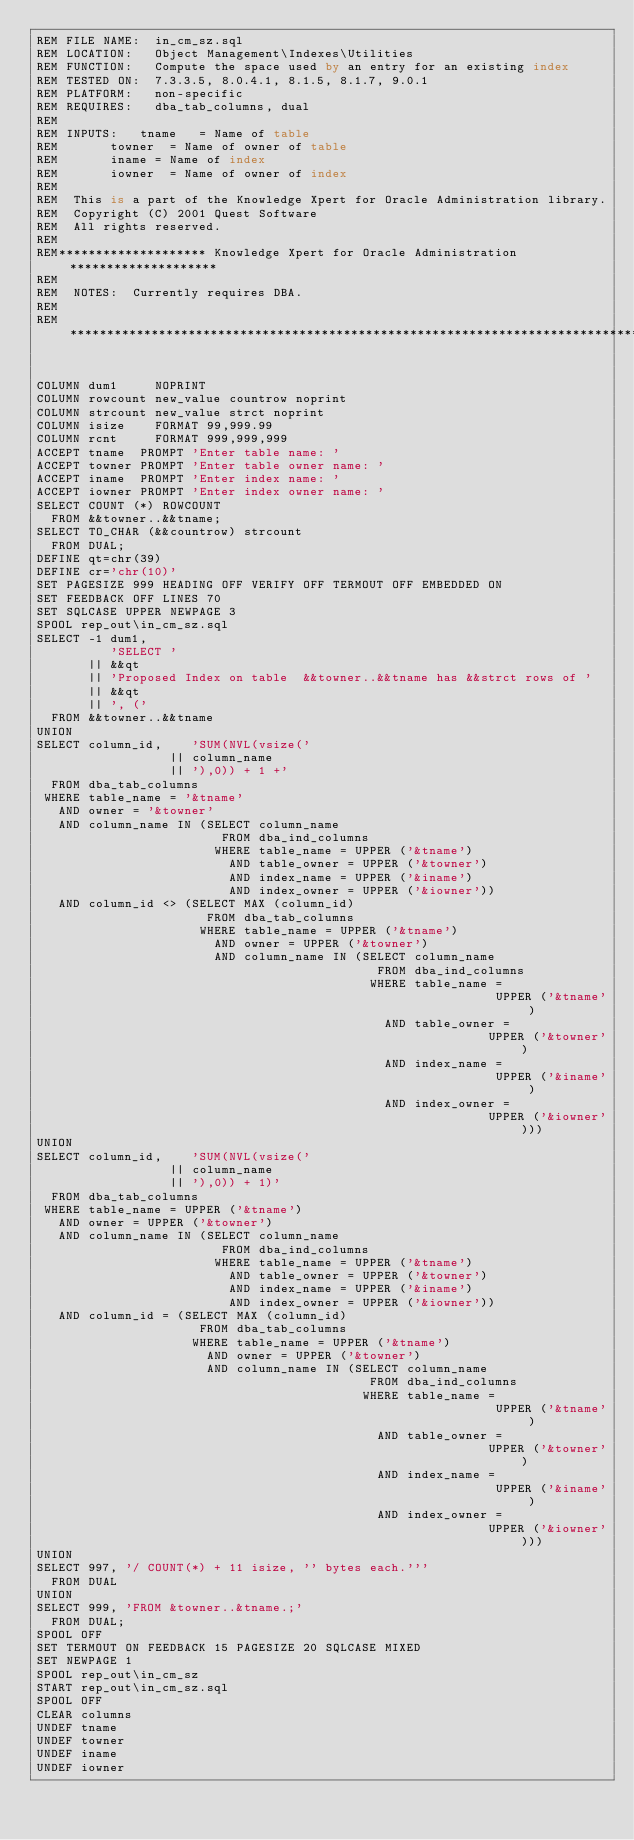<code> <loc_0><loc_0><loc_500><loc_500><_SQL_>REM FILE NAME:  in_cm_sz.sql
REM LOCATION:   Object Management\Indexes\Utilities
REM FUNCTION:   Compute the space used by an entry for an existing index
REM TESTED ON:  7.3.3.5, 8.0.4.1, 8.1.5, 8.1.7, 9.0.1
REM PLATFORM:   non-specific
REM REQUIRES:   dba_tab_columns, dual
REM
REM INPUTS:		tname 	= Name of table
REM				towner	= Name of owner of table
REM				iname	= Name of index
REM				iowner 	= Name of owner of index
REM
REM  This is a part of the Knowledge Xpert for Oracle Administration library. 
REM  Copyright (C) 2001 Quest Software 
REM  All rights reserved. 
REM 
REM******************** Knowledge Xpert for Oracle Administration ********************
REM    
REM  NOTES:  Currently requires DBA.
REM
REM***********************************************************************************


COLUMN dum1     NOPRINT
COLUMN rowcount new_value countrow noprint
COLUMN strcount new_value strct noprint
COLUMN isize    FORMAT 99,999.99
COLUMN rcnt     FORMAT 999,999,999      
ACCEPT tname  PROMPT 'Enter table name: '
ACCEPT towner PROMPT 'Enter table owner name: '
ACCEPT iname  PROMPT 'Enter index name: '
ACCEPT iowner PROMPT 'Enter index owner name: '
SELECT COUNT (*) ROWCOUNT
  FROM &&towner..&&tname;
SELECT TO_CHAR (&&countrow) strcount
  FROM DUAL;
DEFINE qt=chr(39)
DEFINE cr='chr(10)'
SET PAGESIZE 999 HEADING OFF VERIFY OFF TERMOUT OFF EMBEDDED ON
SET FEEDBACK OFF LINES 70
SET SQLCASE UPPER NEWPAGE 3
SPOOL rep_out\in_cm_sz.sql
SELECT -1 dum1,
          'SELECT '
       || &&qt
       || 'Proposed Index on table  &&towner..&&tname has &&strct rows of '
       || &&qt
       || ', ('
  FROM &&towner..&&tname
UNION
SELECT column_id,    'SUM(NVL(vsize('
                  || column_name
                  || '),0)) + 1 +'
  FROM dba_tab_columns
 WHERE table_name = '&tname'
   AND owner = '&towner'
   AND column_name IN (SELECT column_name
                         FROM dba_ind_columns
                        WHERE table_name = UPPER ('&tname')
                          AND table_owner = UPPER ('&towner')
                          AND index_name = UPPER ('&iname')
                          AND index_owner = UPPER ('&iowner'))
   AND column_id <> (SELECT MAX (column_id)
                       FROM dba_tab_columns
                      WHERE table_name = UPPER ('&tname')
                        AND owner = UPPER ('&towner')
                        AND column_name IN (SELECT column_name
                                              FROM dba_ind_columns
                                             WHERE table_name =
                                                              UPPER ('&tname')
                                               AND table_owner =
                                                             UPPER ('&towner')
                                               AND index_name =
                                                              UPPER ('&iname')
                                               AND index_owner =
                                                             UPPER ('&iowner')))
UNION
SELECT column_id,    'SUM(NVL(vsize('
                  || column_name
                  || '),0)) + 1)'
  FROM dba_tab_columns
 WHERE table_name = UPPER ('&tname')
   AND owner = UPPER ('&towner')
   AND column_name IN (SELECT column_name
                         FROM dba_ind_columns
                        WHERE table_name = UPPER ('&tname')
                          AND table_owner = UPPER ('&towner')
                          AND index_name = UPPER ('&iname')
                          AND index_owner = UPPER ('&iowner'))
   AND column_id = (SELECT MAX (column_id)
                      FROM dba_tab_columns
                     WHERE table_name = UPPER ('&tname')
                       AND owner = UPPER ('&towner')
                       AND column_name IN (SELECT column_name
                                             FROM dba_ind_columns
                                            WHERE table_name =
                                                              UPPER ('&tname')
                                              AND table_owner =
                                                             UPPER ('&towner')
                                              AND index_name =
                                                              UPPER ('&iname')
                                              AND index_owner =
                                                             UPPER ('&iowner')))
UNION
SELECT 997, '/ COUNT(*) + 11 isize, '' bytes each.'''
  FROM DUAL
UNION
SELECT 999, 'FROM &towner..&tname.;'
  FROM DUAL;
SPOOL OFF
SET TERMOUT ON FEEDBACK 15 PAGESIZE 20 SQLCASE MIXED 
SET NEWPAGE 1
SPOOL rep_out\in_cm_sz
START rep_out\in_cm_sz.sql
SPOOL OFF
CLEAR columns
UNDEF tname
UNDEF towner
UNDEF iname
UNDEF iowner
</code> 